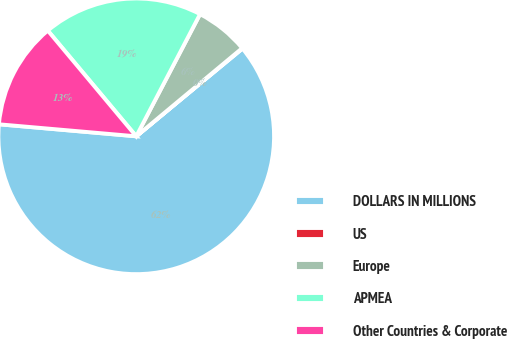Convert chart to OTSL. <chart><loc_0><loc_0><loc_500><loc_500><pie_chart><fcel>DOLLARS IN MILLIONS<fcel>US<fcel>Europe<fcel>APMEA<fcel>Other Countries & Corporate<nl><fcel>62.37%<fcel>0.06%<fcel>6.29%<fcel>18.75%<fcel>12.52%<nl></chart> 